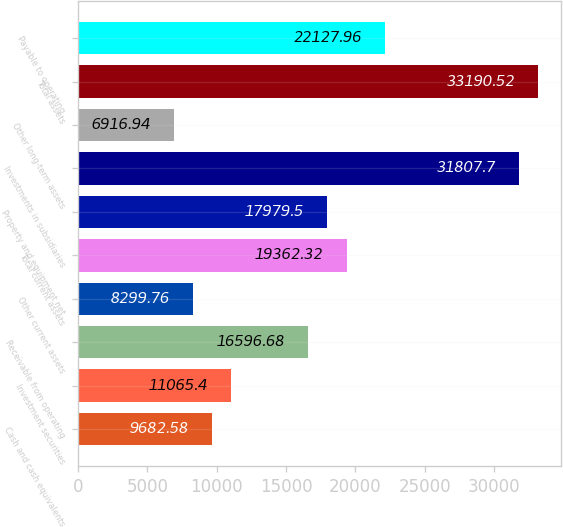Convert chart to OTSL. <chart><loc_0><loc_0><loc_500><loc_500><bar_chart><fcel>Cash and cash equivalents<fcel>Investment securities<fcel>Receivable from operating<fcel>Other current assets<fcel>Total current assets<fcel>Property and equipment net<fcel>Investments in subsidiaries<fcel>Other long-term assets<fcel>Total assets<fcel>Payable to operating<nl><fcel>9682.58<fcel>11065.4<fcel>16596.7<fcel>8299.76<fcel>19362.3<fcel>17979.5<fcel>31807.7<fcel>6916.94<fcel>33190.5<fcel>22128<nl></chart> 